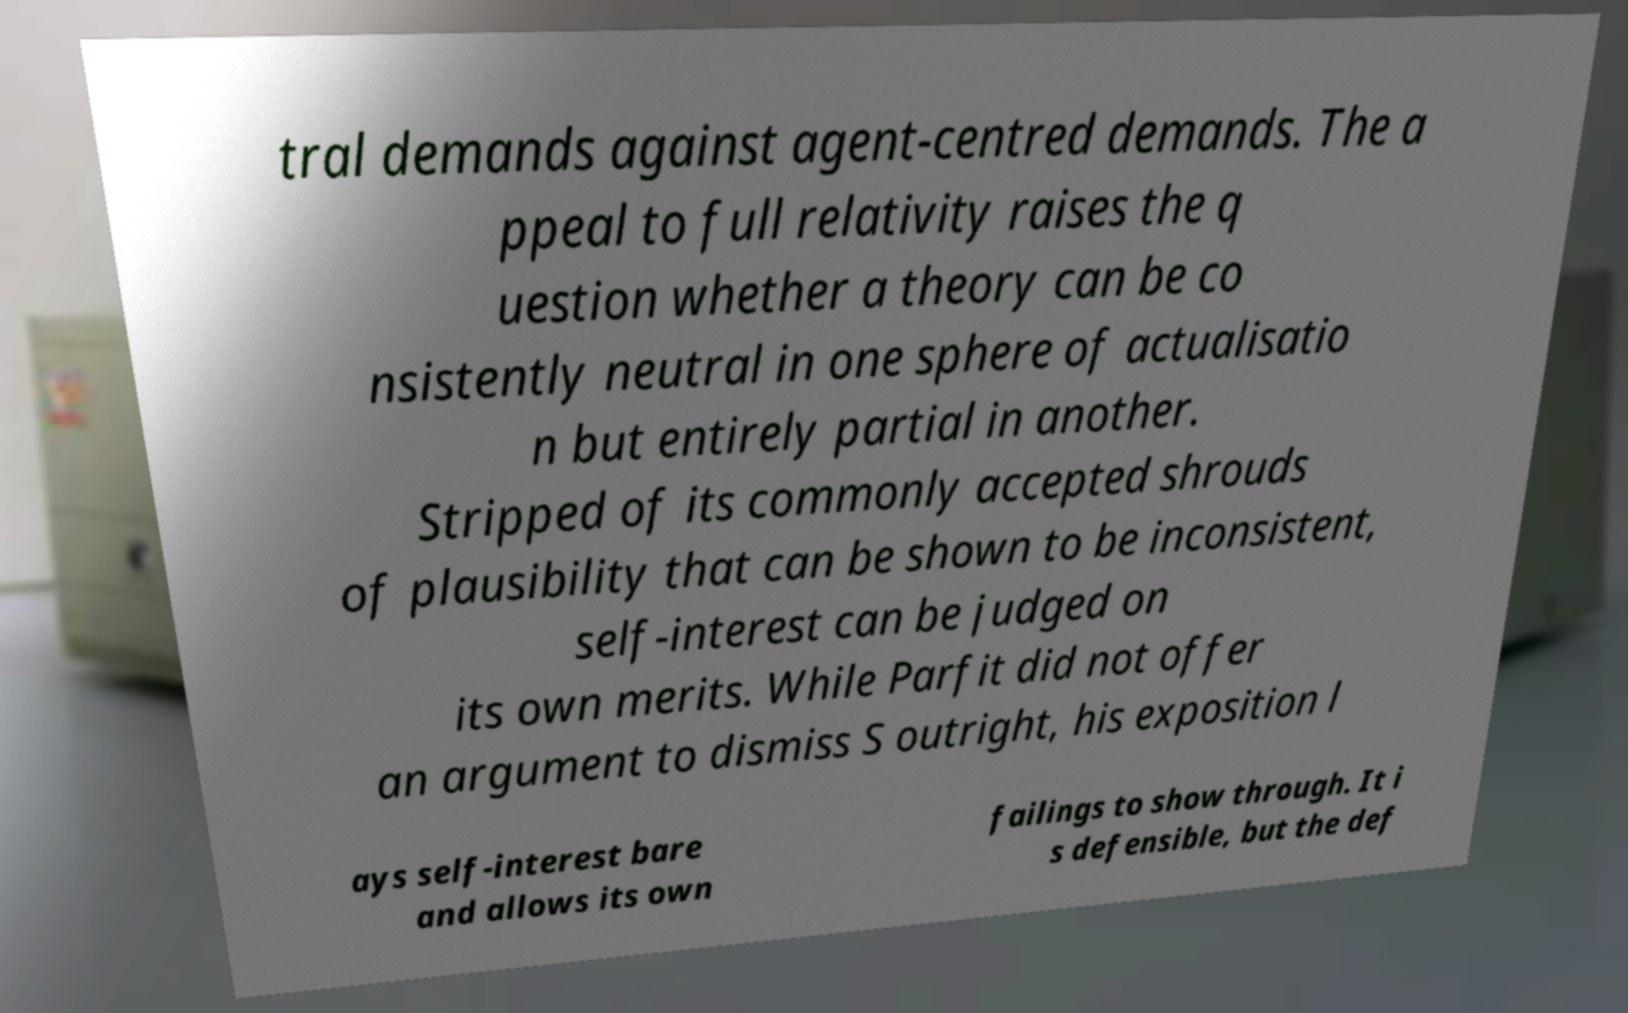Could you assist in decoding the text presented in this image and type it out clearly? tral demands against agent-centred demands. The a ppeal to full relativity raises the q uestion whether a theory can be co nsistently neutral in one sphere of actualisatio n but entirely partial in another. Stripped of its commonly accepted shrouds of plausibility that can be shown to be inconsistent, self-interest can be judged on its own merits. While Parfit did not offer an argument to dismiss S outright, his exposition l ays self-interest bare and allows its own failings to show through. It i s defensible, but the def 